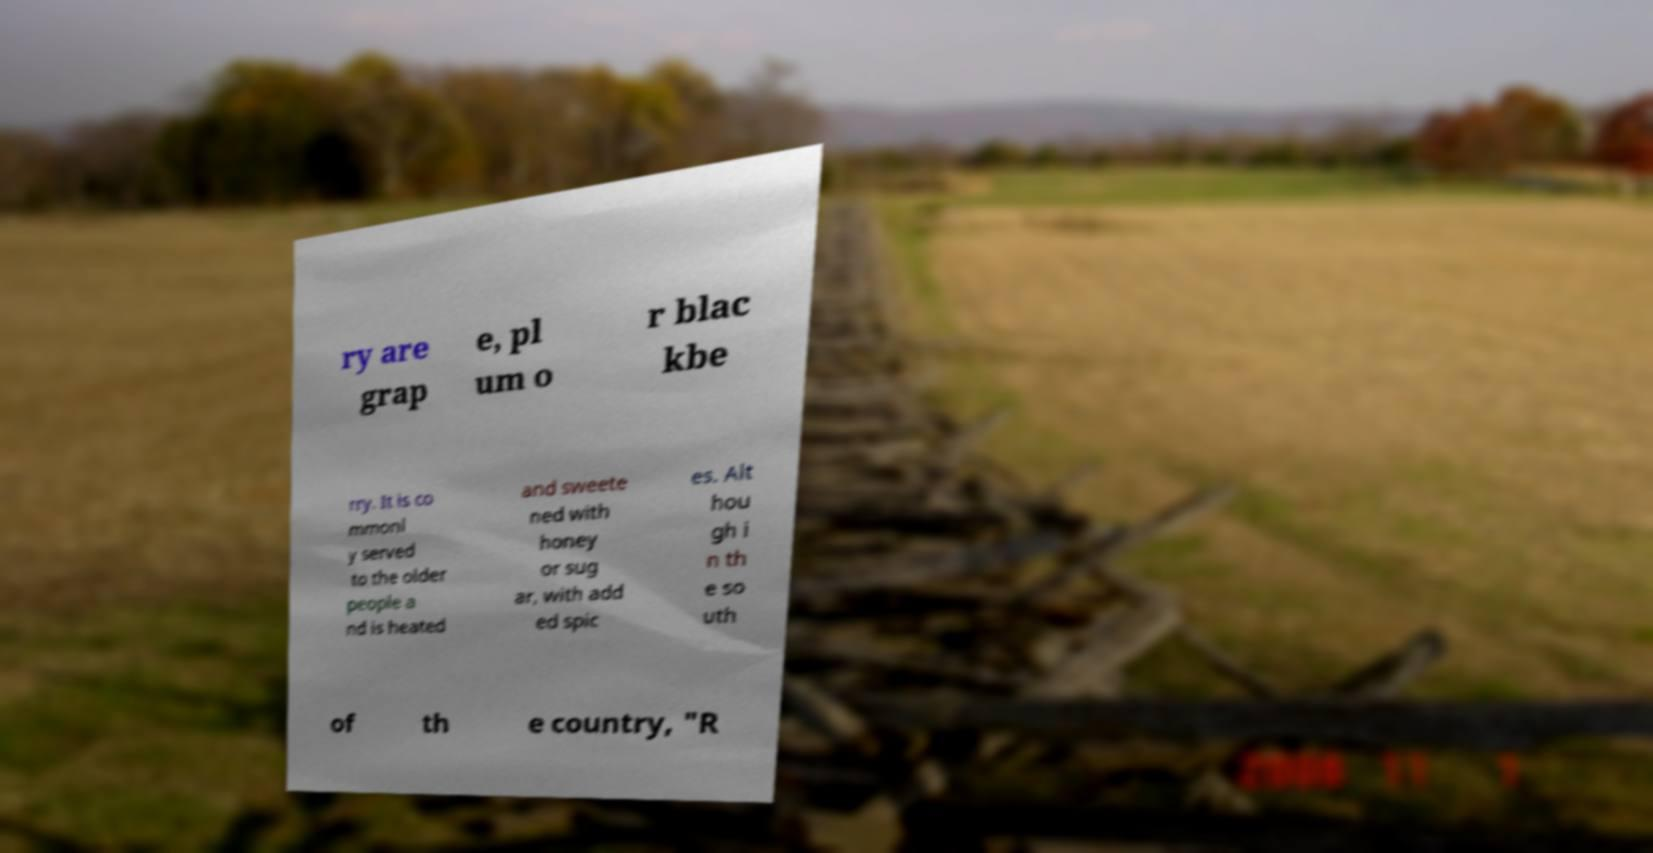I need the written content from this picture converted into text. Can you do that? ry are grap e, pl um o r blac kbe rry. It is co mmonl y served to the older people a nd is heated and sweete ned with honey or sug ar, with add ed spic es. Alt hou gh i n th e so uth of th e country, "R 